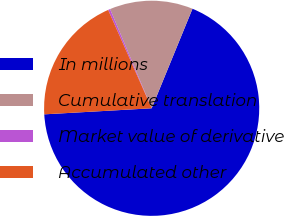Convert chart. <chart><loc_0><loc_0><loc_500><loc_500><pie_chart><fcel>In millions<fcel>Cumulative translation<fcel>Market value of derivative<fcel>Accumulated other<nl><fcel>67.91%<fcel>12.51%<fcel>0.31%<fcel>19.27%<nl></chart> 